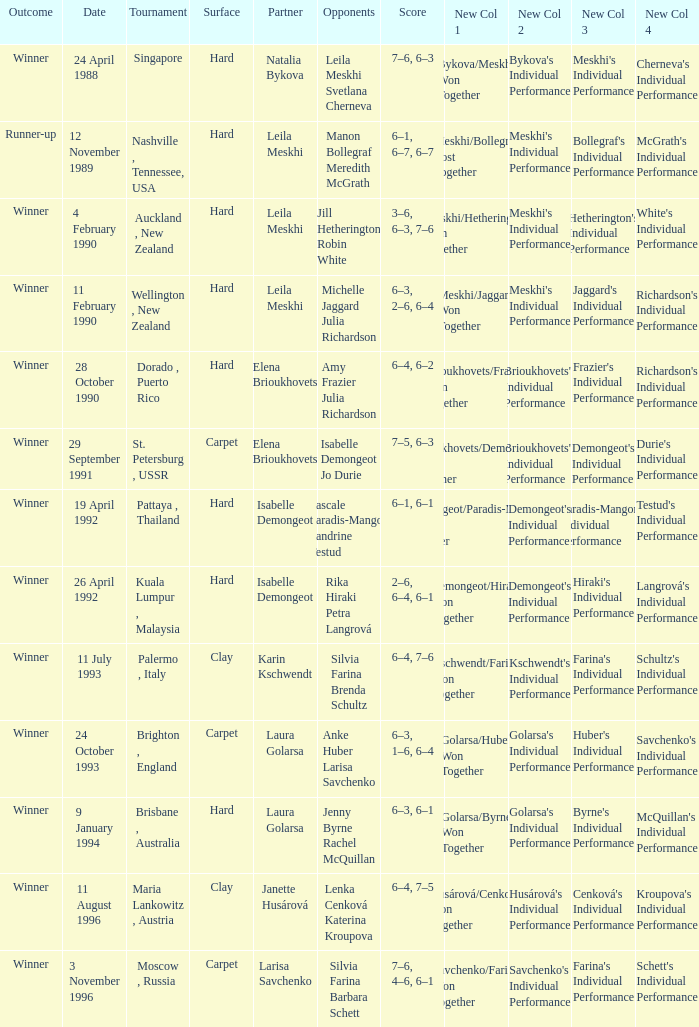On what Date was the Score 6–4, 6–2? 28 October 1990. 